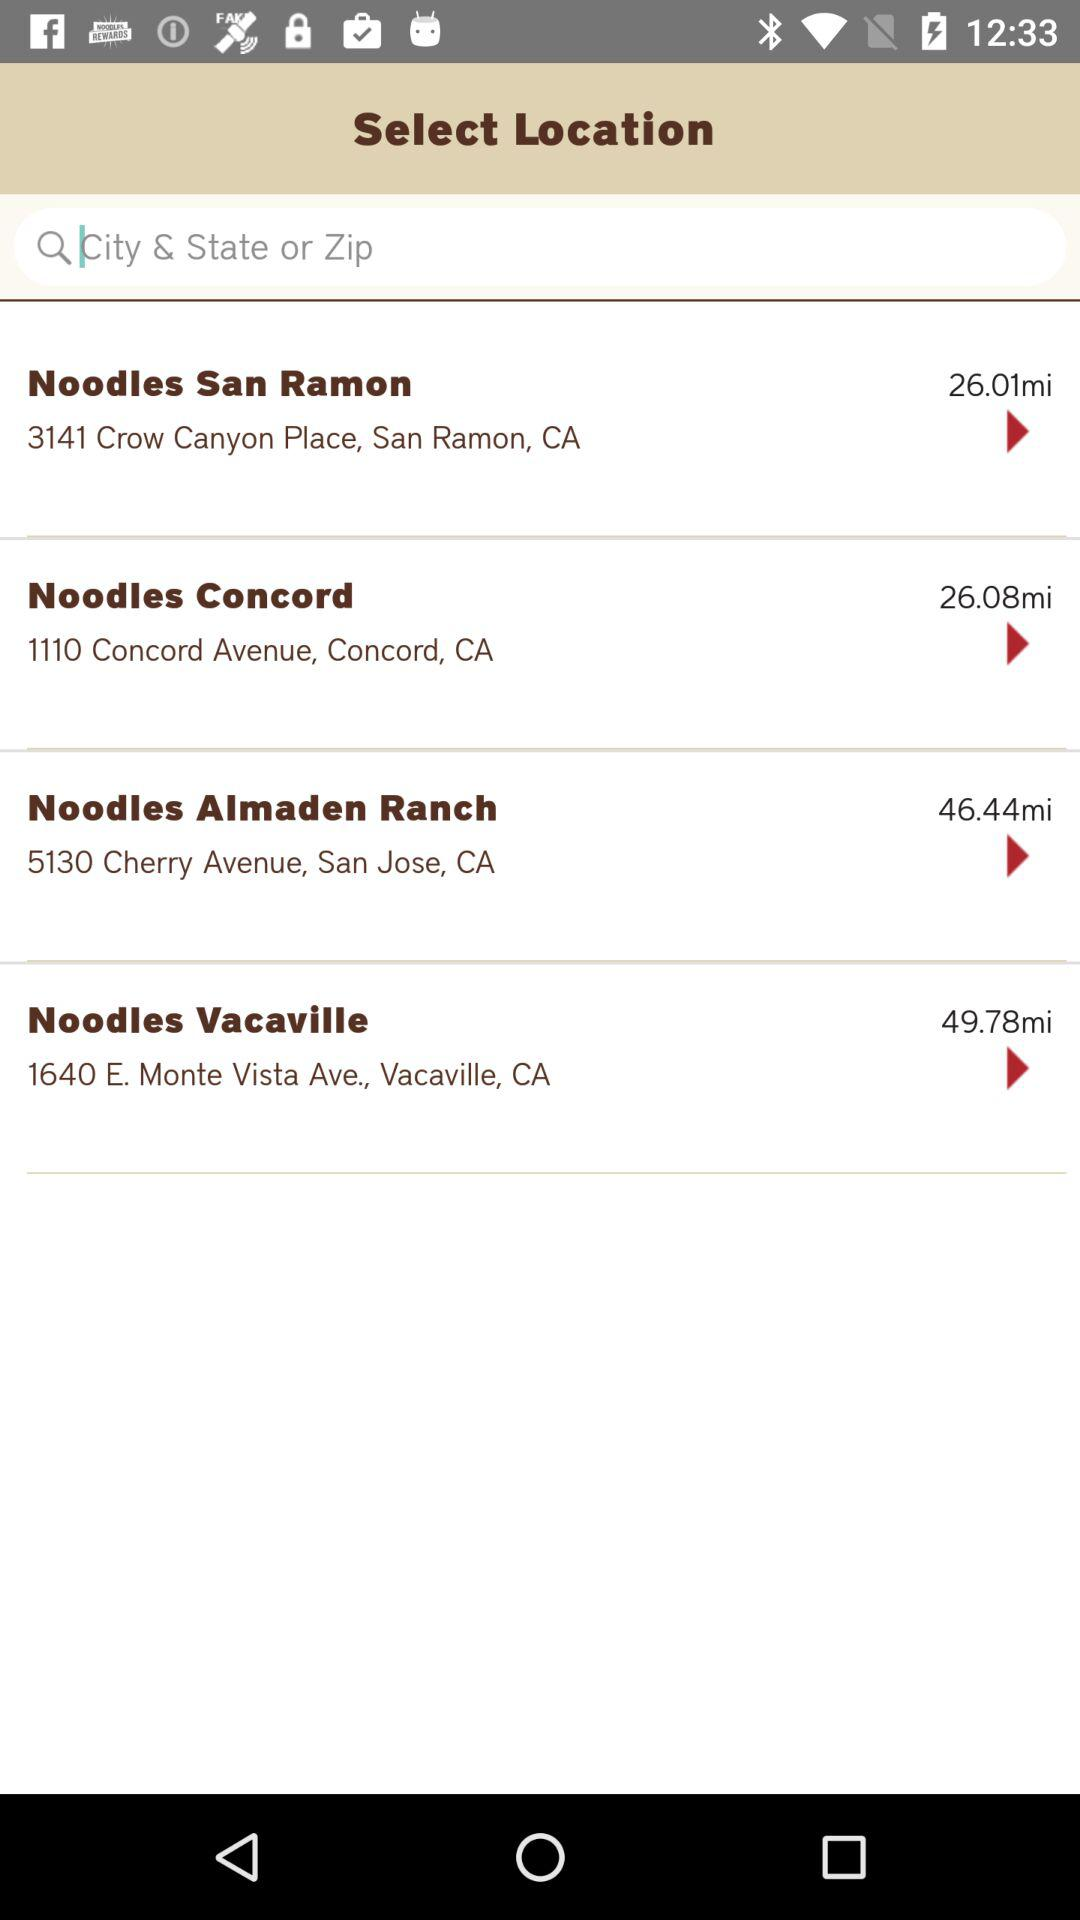What is the address of Noodles Concord? The address is 110 Concord Avenue, Concord, CA. 